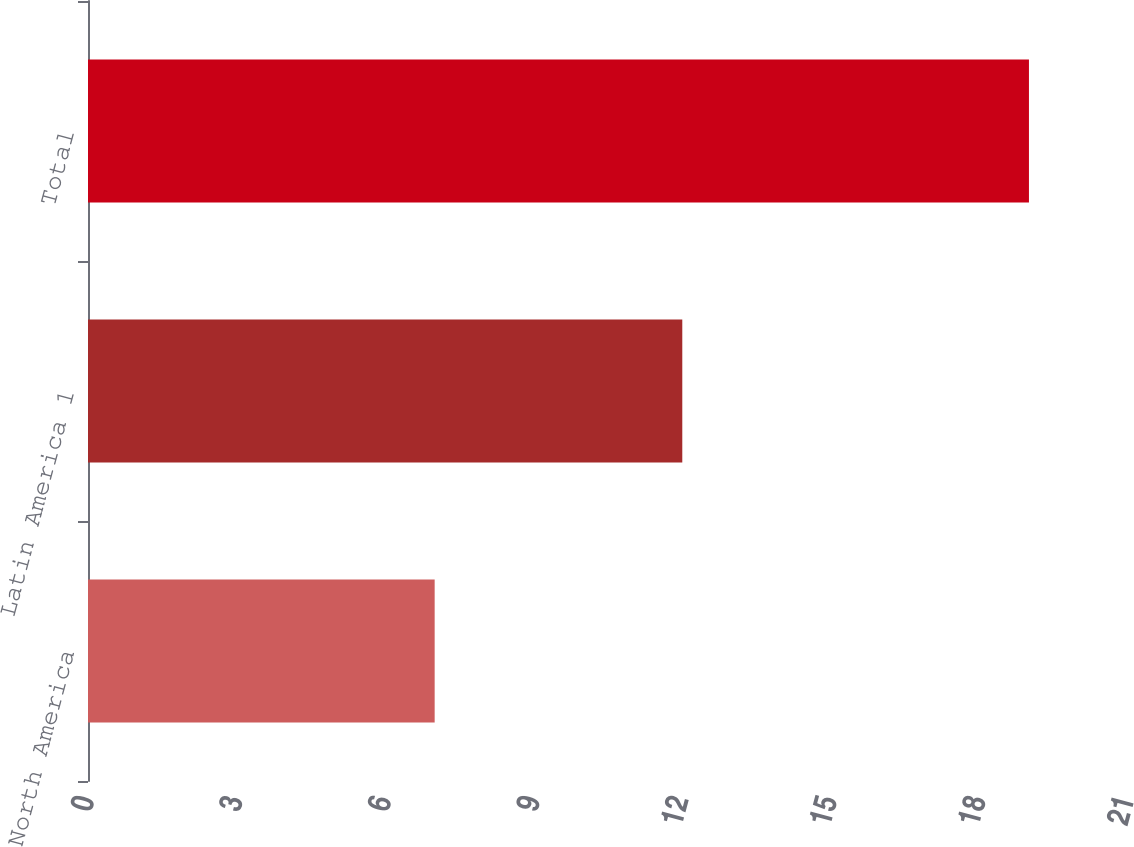<chart> <loc_0><loc_0><loc_500><loc_500><bar_chart><fcel>North America<fcel>Latin America 1<fcel>Total<nl><fcel>7<fcel>12<fcel>19<nl></chart> 